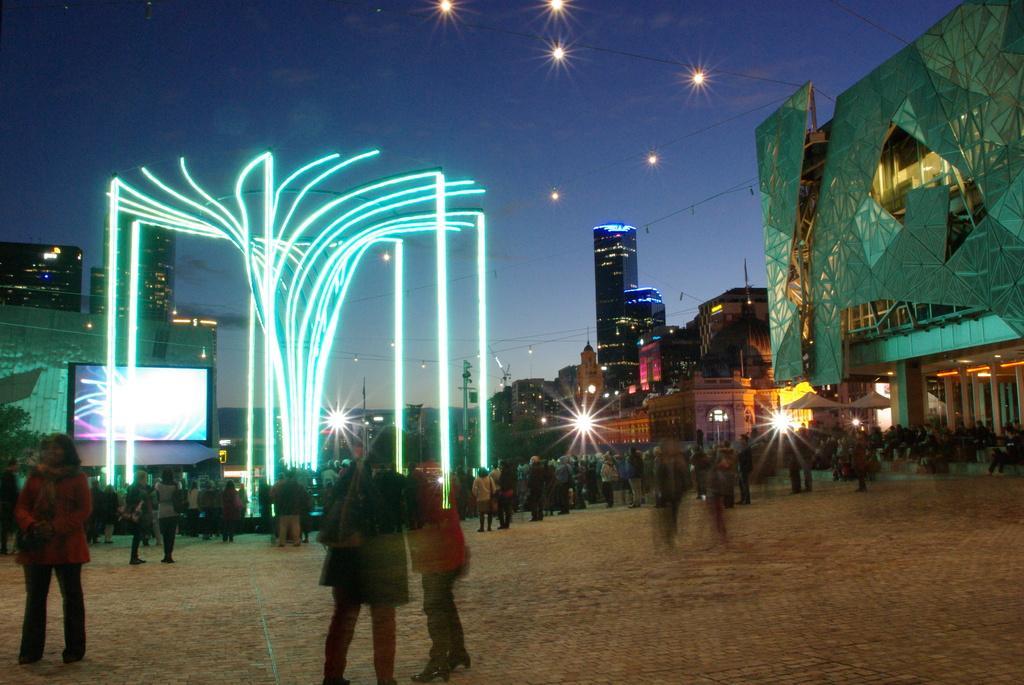Could you give a brief overview of what you see in this image? This image is clicked on a street, there are many people walking and standing on the land, on the left side there is a screen to the building, in the back there are many buildings all over the image with lights in front of it and above its sky with lights. 